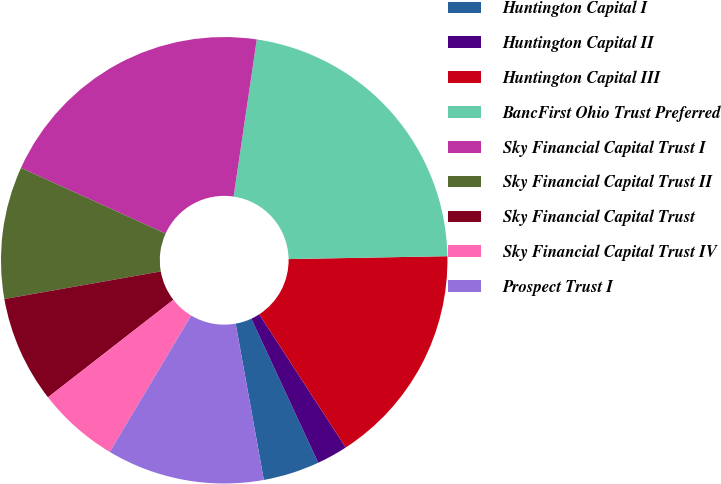Convert chart to OTSL. <chart><loc_0><loc_0><loc_500><loc_500><pie_chart><fcel>Huntington Capital I<fcel>Huntington Capital II<fcel>Huntington Capital III<fcel>BancFirst Ohio Trust Preferred<fcel>Sky Financial Capital Trust I<fcel>Sky Financial Capital Trust II<fcel>Sky Financial Capital Trust<fcel>Sky Financial Capital Trust IV<fcel>Prospect Trust I<nl><fcel>4.08%<fcel>2.24%<fcel>16.13%<fcel>22.38%<fcel>20.54%<fcel>9.57%<fcel>7.74%<fcel>5.91%<fcel>11.41%<nl></chart> 